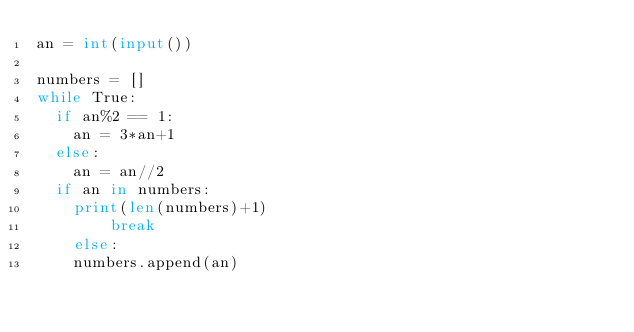<code> <loc_0><loc_0><loc_500><loc_500><_Python_>an = int(input())

numbers = []
while True:
	if an%2 == 1:
		an = 3*an+1
	else:
		an = an//2
	if an in numbers:
		print(len(numbers)+1)
        break
    else:
		numbers.append(an)</code> 